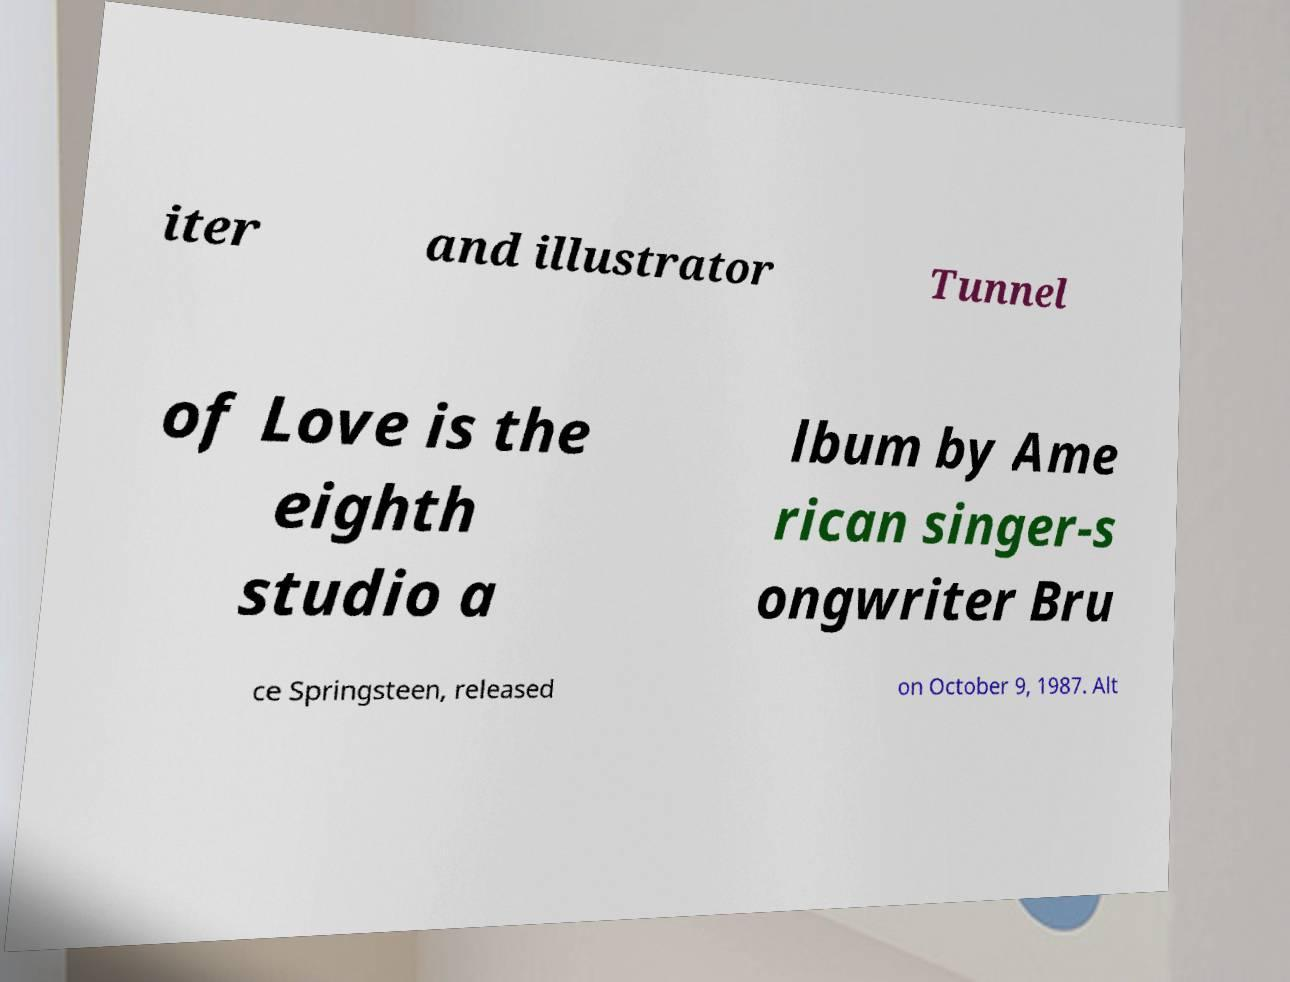Can you accurately transcribe the text from the provided image for me? iter and illustrator Tunnel of Love is the eighth studio a lbum by Ame rican singer-s ongwriter Bru ce Springsteen, released on October 9, 1987. Alt 